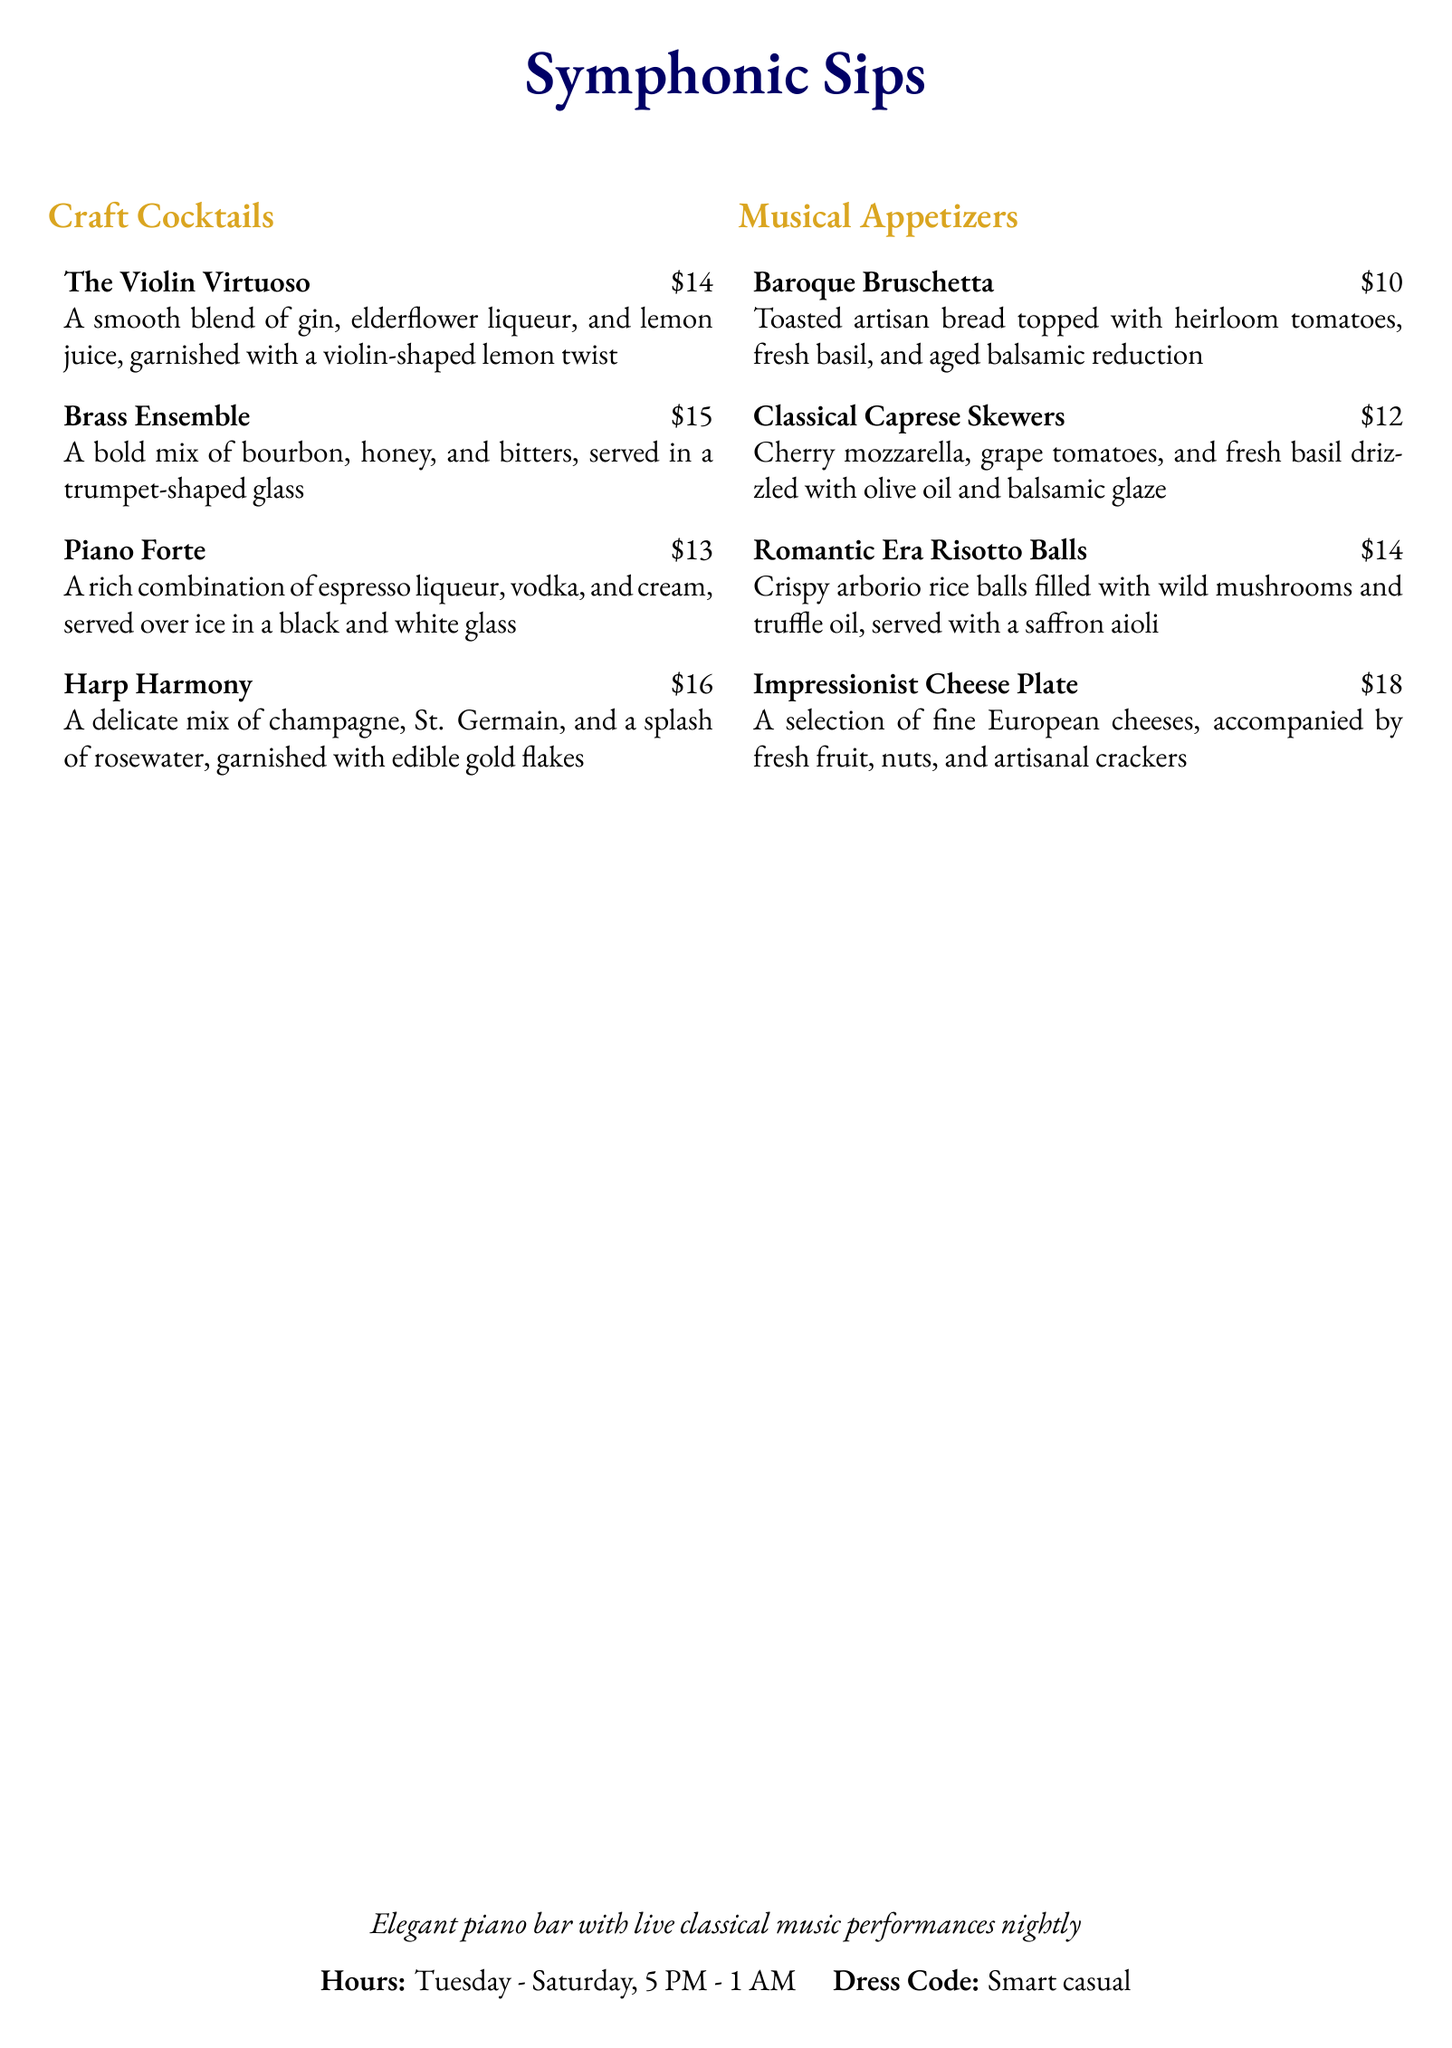What is the name of the first cocktail? The first cocktail listed is "The Violin Virtuoso."
Answer: The Violin Virtuoso What is the price of the Harp Harmony cocktail? The price listed for the Harp Harmony is $16.
Answer: $16 How many types of musical appetizers are there? There are four types of musical appetizers mentioned in the document.
Answer: Four What ingredients are in the Classical Caprese Skewers? The Classical Caprese Skewers are made with cherry mozzarella, grape tomatoes, and fresh basil.
Answer: Cherry mozzarella, grape tomatoes, and fresh basil What is the dress code for the piano bar? The dress code specified is "Smart casual."
Answer: Smart casual Which appetizer is inspired by the Romantic Era? The appetizer called "Romantic Era Risotto Balls" is inspired by the Romantic Era.
Answer: Romantic Era Risotto Balls What type of music is performed at the bar? The document mentions that live classical music performances occur nightly.
Answer: Classical music What are the operating hours of the piano bar? The operating hours listed are from Tuesday to Saturday, 5 PM to 1 AM.
Answer: Tuesday - Saturday, 5 PM - 1 AM 